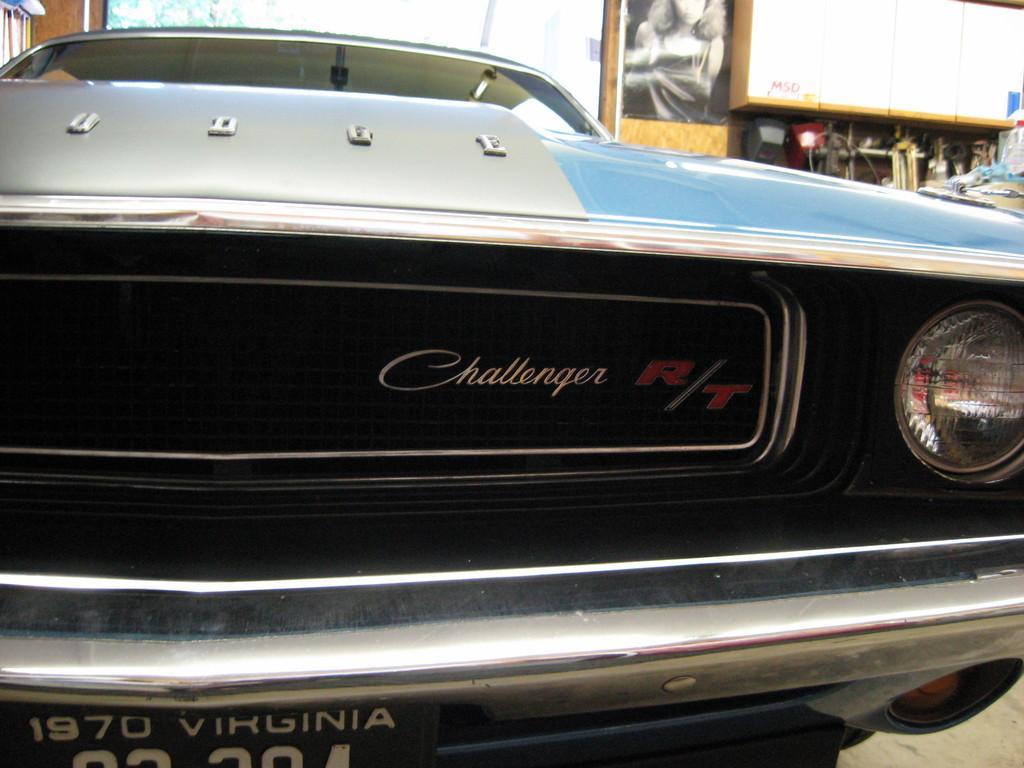Can you describe this image briefly? Here I can see a car. In the background there is a shed and a board to which a poster is attached. 